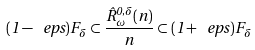Convert formula to latex. <formula><loc_0><loc_0><loc_500><loc_500>( 1 - \ e p s ) F _ { \delta } \subset \frac { { \hat { R } } _ { \omega } ^ { 0 , \delta } ( n ) } { n } \subset ( 1 + \ e p s ) F _ { \delta }</formula> 